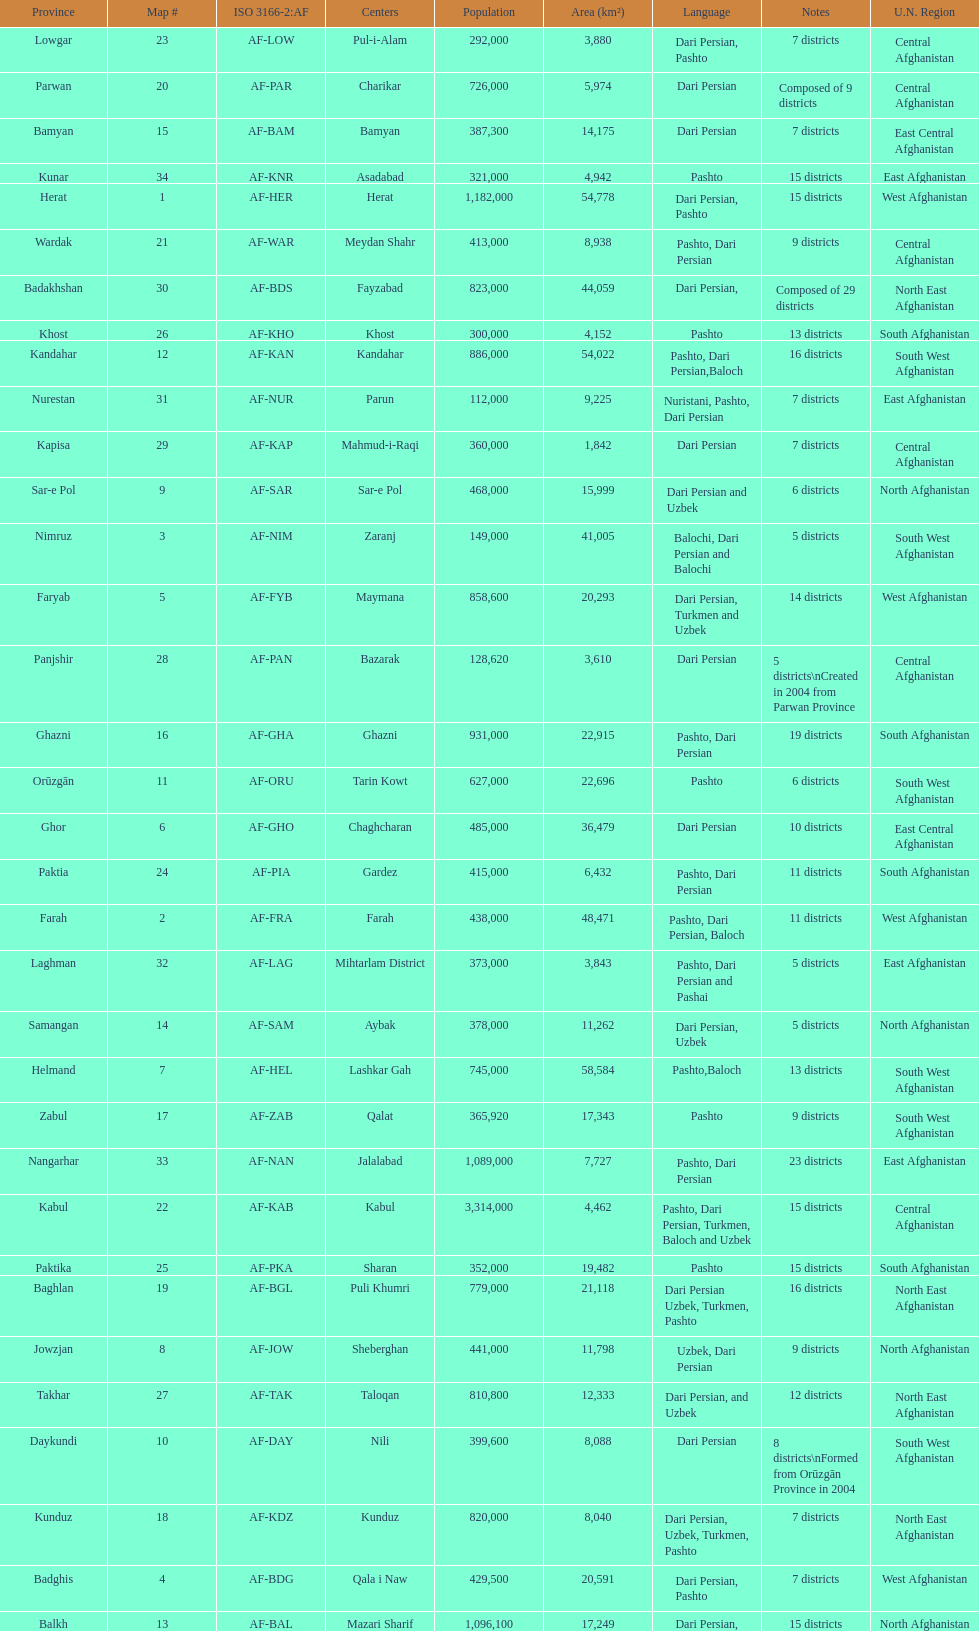How many provinces in afghanistan speak dari persian? 28. 